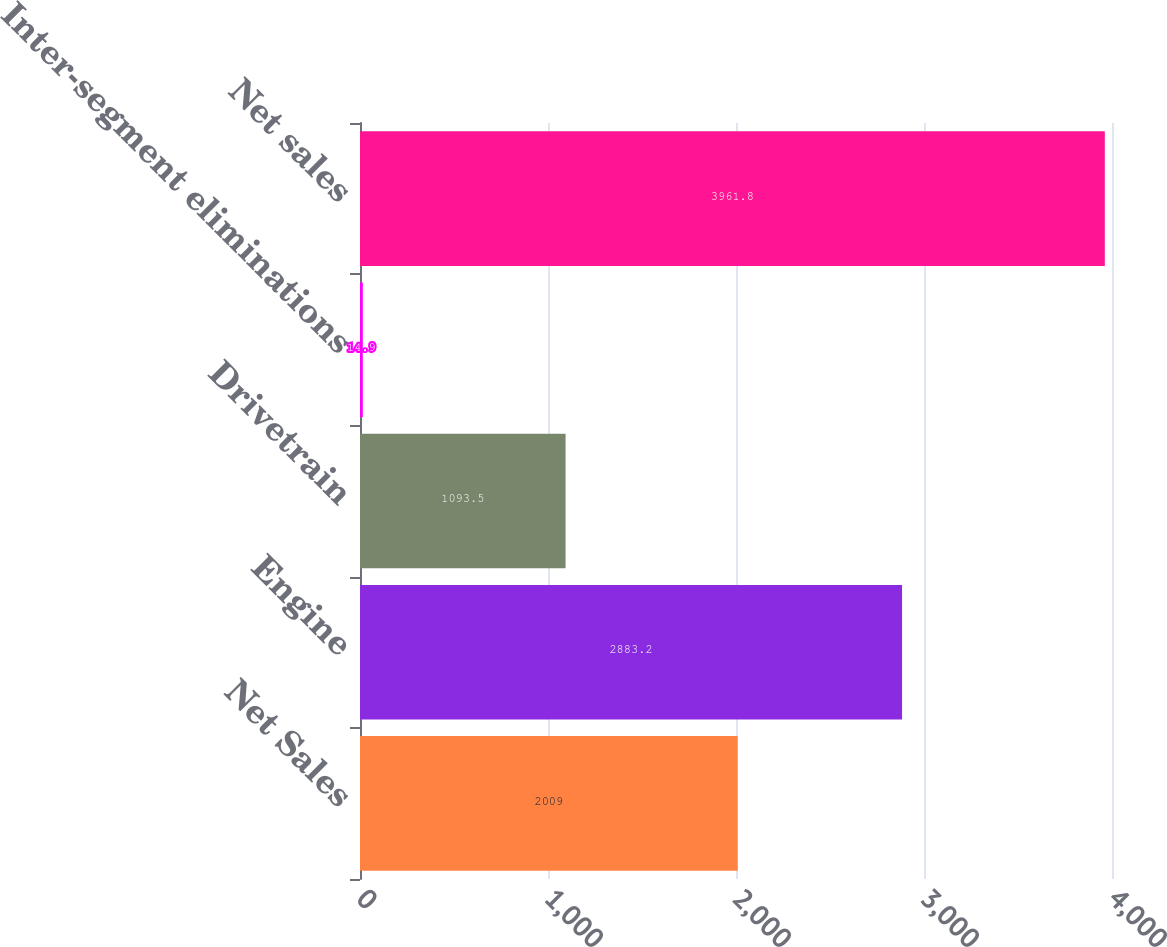Convert chart. <chart><loc_0><loc_0><loc_500><loc_500><bar_chart><fcel>Net Sales<fcel>Engine<fcel>Drivetrain<fcel>Inter-segment eliminations<fcel>Net sales<nl><fcel>2009<fcel>2883.2<fcel>1093.5<fcel>14.9<fcel>3961.8<nl></chart> 